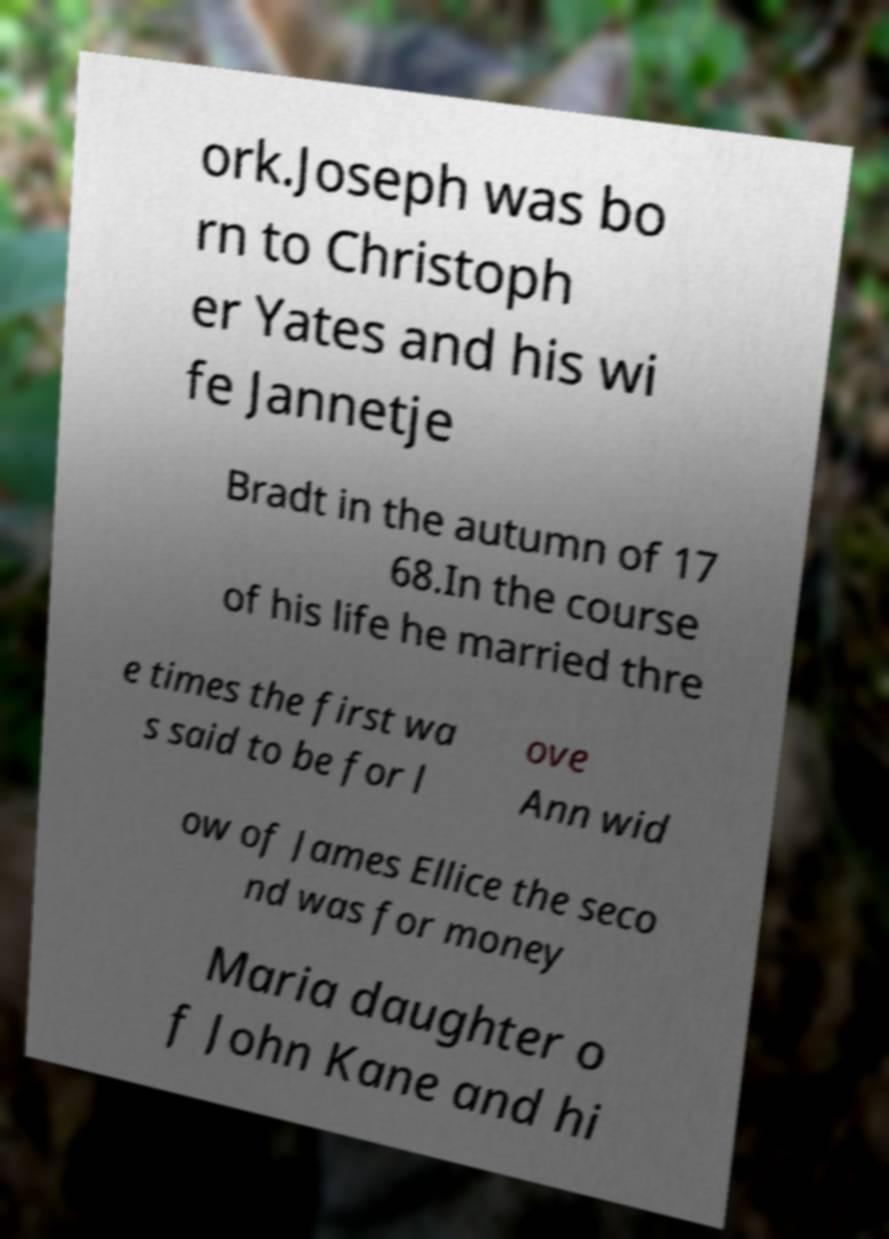There's text embedded in this image that I need extracted. Can you transcribe it verbatim? ork.Joseph was bo rn to Christoph er Yates and his wi fe Jannetje Bradt in the autumn of 17 68.In the course of his life he married thre e times the first wa s said to be for l ove Ann wid ow of James Ellice the seco nd was for money Maria daughter o f John Kane and hi 